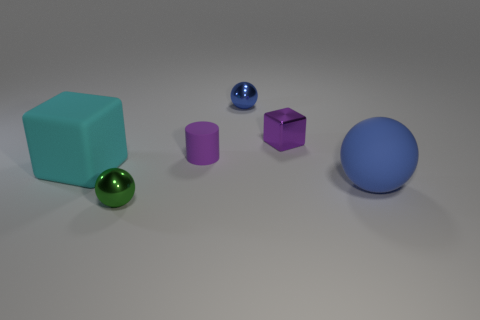Add 1 tiny green metallic balls. How many objects exist? 7 Subtract all shiny spheres. How many spheres are left? 1 Subtract all yellow cylinders. How many blue spheres are left? 2 Subtract 1 spheres. How many spheres are left? 2 Subtract all cylinders. How many objects are left? 5 Add 6 metal cubes. How many metal cubes exist? 7 Subtract 0 yellow balls. How many objects are left? 6 Subtract all green cylinders. Subtract all gray balls. How many cylinders are left? 1 Subtract all cyan rubber things. Subtract all big red balls. How many objects are left? 5 Add 5 small green objects. How many small green objects are left? 6 